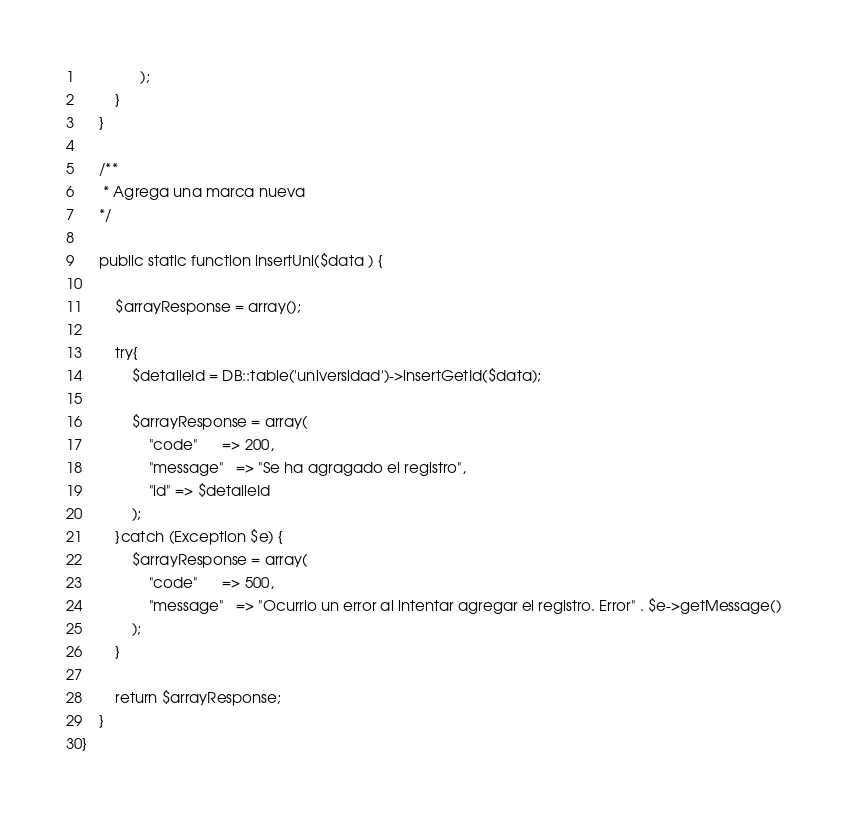<code> <loc_0><loc_0><loc_500><loc_500><_PHP_>              );
        }
    }

    /**
     * Agrega una marca nueva
    */

    public static function insertUni($data ) {

        $arrayResponse = array();

        try{
            $detalleId = DB::table('universidad')->insertGetId($data);
            
            $arrayResponse = array(
                "code"      => 200,
                "message"   => "Se ha agragado el registro",
                "id" => $detalleId
            );
        }catch (Exception $e) {
            $arrayResponse = array(
                "code"      => 500,
                "message"   => "Ocurrio un error al intentar agregar el registro. Error" . $e->getMessage()
            );
        }

        return $arrayResponse;
    }
}
</code> 